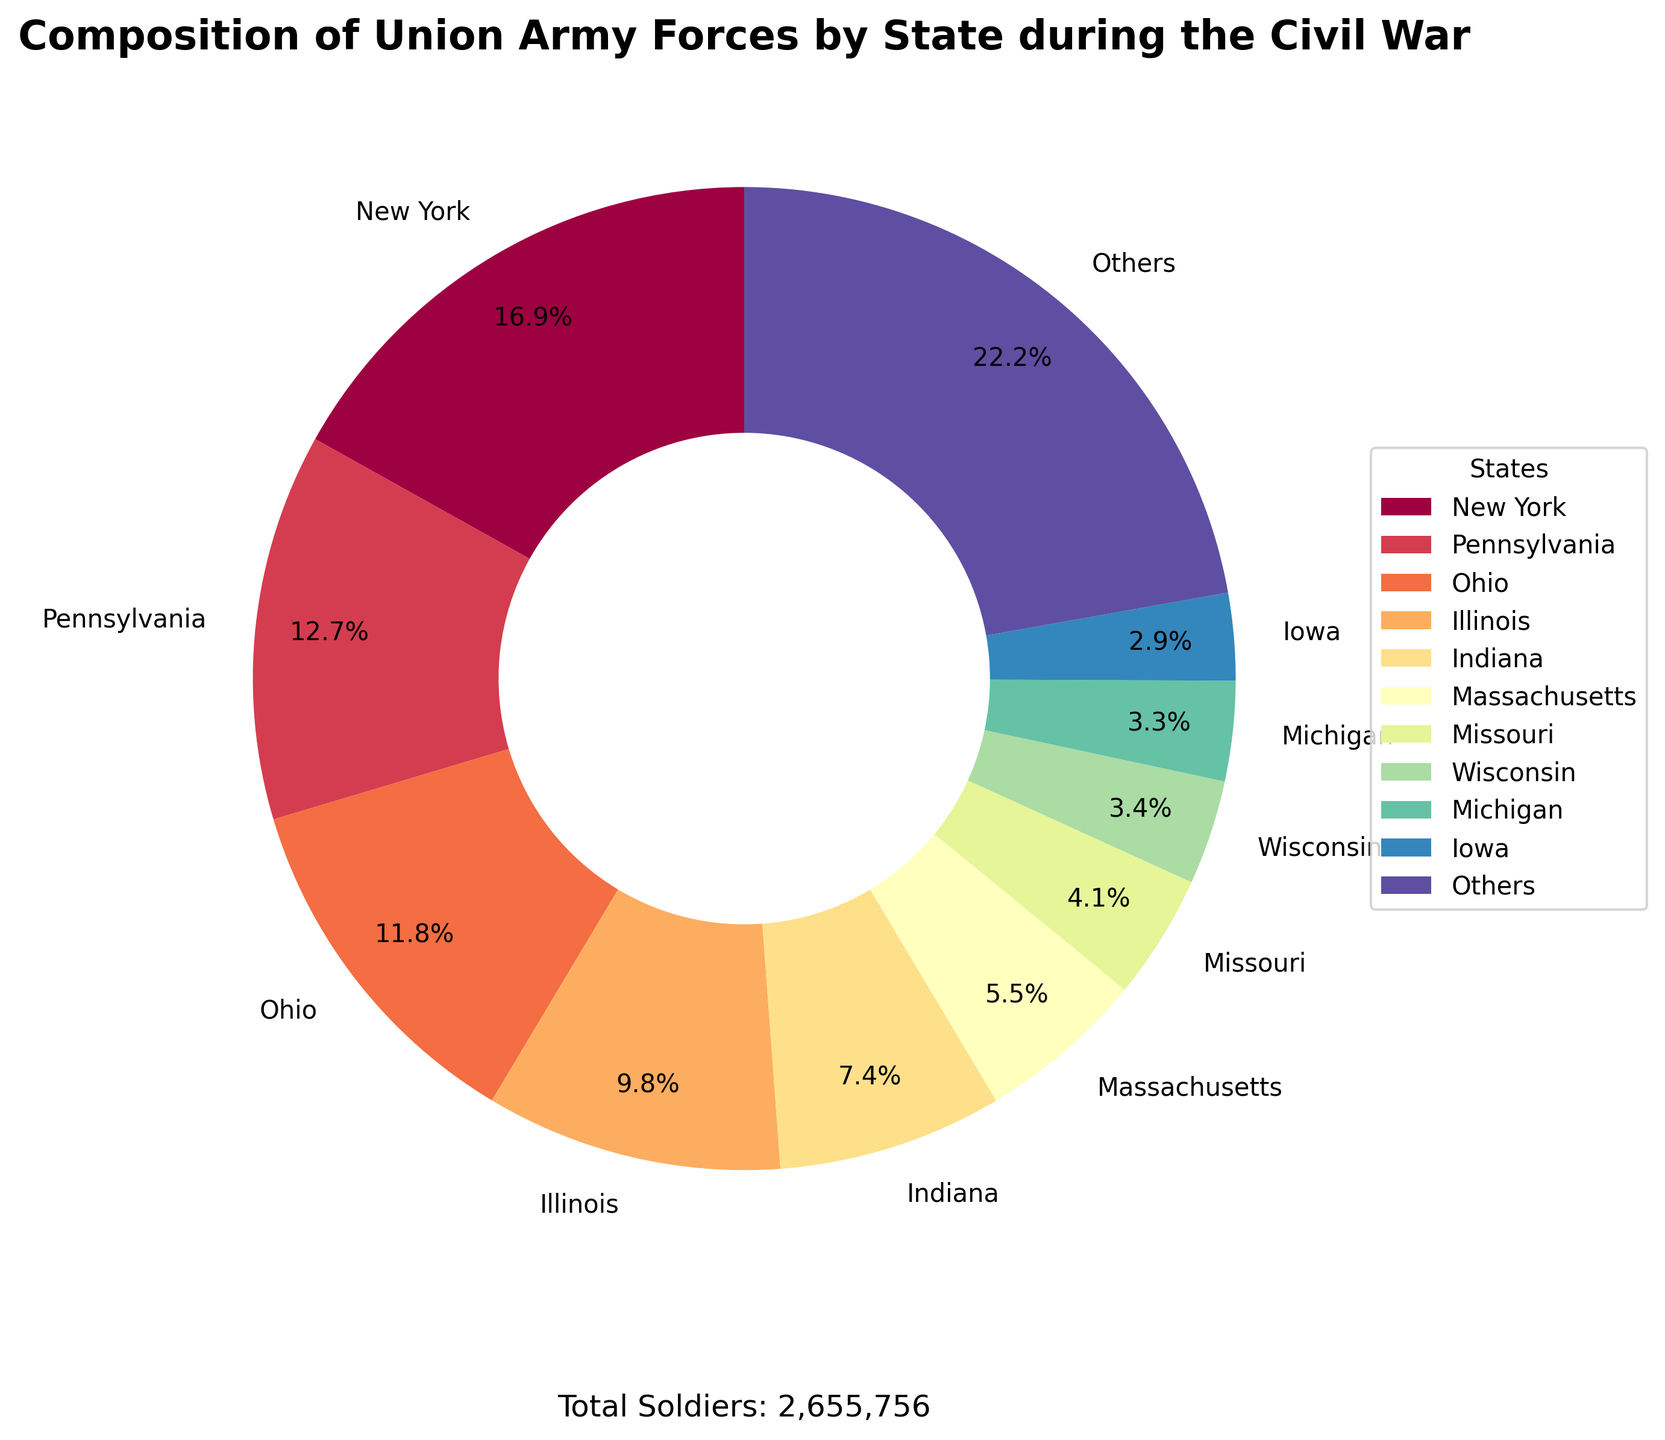What percentage of the Union Army forces were contributed by the top 10 states combined? Sum up the percentages of the top 10 states from the pie chart and compare it to the total percentage (100%).
Answer: Approximately 79.5% Which state contributed the largest number of soldiers? Identify the state with the largest section or highest percentage in the pie chart.
Answer: New York How many more soldiers did New York contribute compared to Pennsylvania? Subtract the number of soldiers contributed by Pennsylvania from the number contributed by New York: 448,850 - 337,936.
Answer: 110,914 What is the total percentage of soldiers contributed by "Others"? Identify the slice labeled "Others" and read its percentage from the pie chart.
Answer: Approximately 20.5% Which state contributed the smallest number of soldiers among the top 10 states? Identify the state with the smallest section or percentage among the top 10 states in the pie chart.
Answer: Iowa Which state has a larger contribution, Ohio or Illinois? Compare the sizes of the sections labeled Ohio and Illinois in the pie chart.
Answer: Ohio How much percentage did Illinois contribute to the Union Army forces? Identify the slice labeled Illinois and read its percentage from the pie chart.
Answer: Approximately 8.2% By how much is the contribution of Massachusetts larger than that of Missouri? Subtract the percentage contribution of Missouri from that of Massachusetts: 8.2% - 6.0%.
Answer: 2.2% What is the total number of soldiers contributed by the states shown as "Others"? Identify the percentage contribution of the "Others" section and convert it to the number of soldiers: 20.5% of 2,186,597.
Answer: Approximately 447,256 What percentage more did Pennsylvania contribute compared to Indiana? Divide the difference in percentages between Pennsylvania and Indiana by Indiana's percentage: (15.5% - 8.7%) / 8.7% and then multiply by 100.
Answer: Approximately 78% 